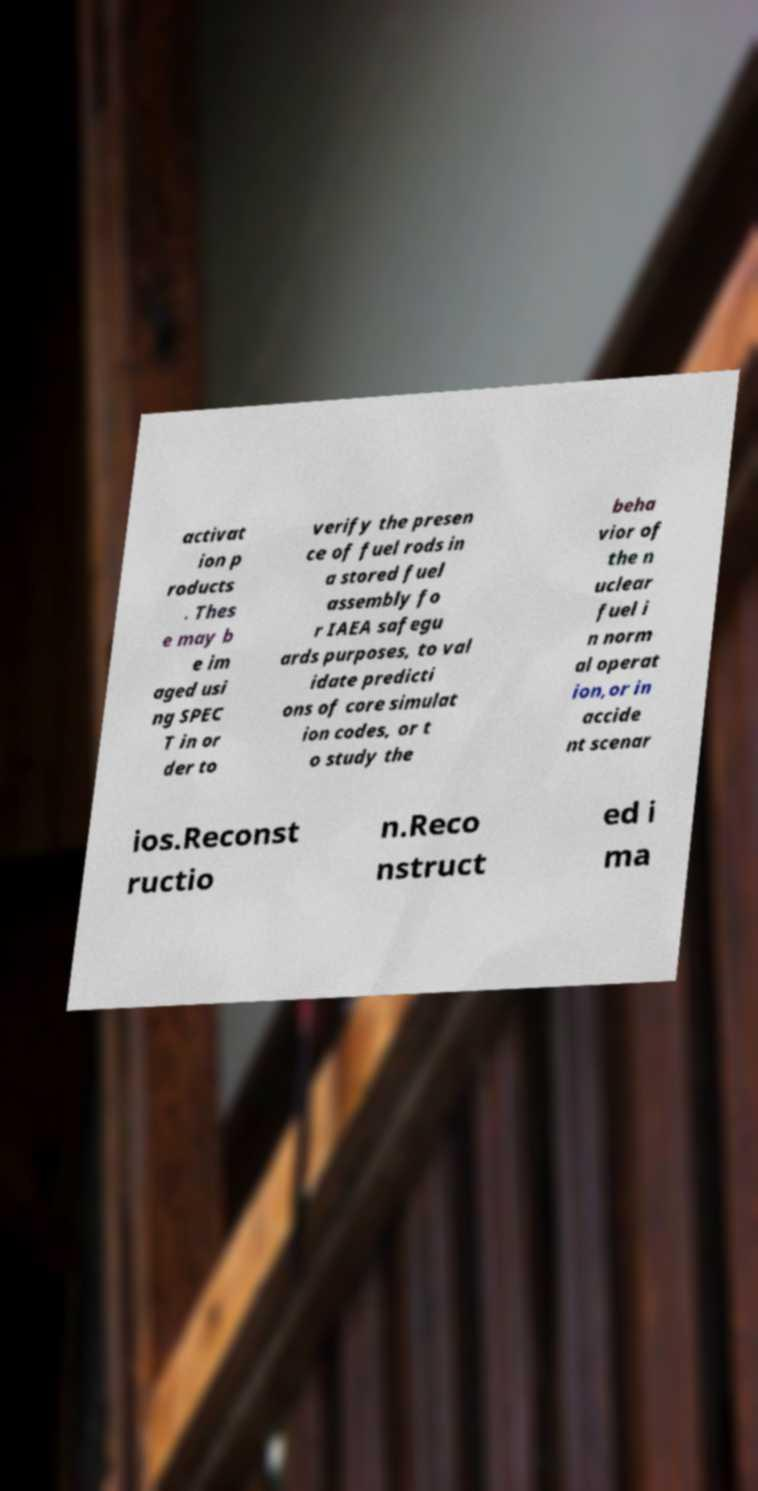Could you extract and type out the text from this image? activat ion p roducts . Thes e may b e im aged usi ng SPEC T in or der to verify the presen ce of fuel rods in a stored fuel assembly fo r IAEA safegu ards purposes, to val idate predicti ons of core simulat ion codes, or t o study the beha vior of the n uclear fuel i n norm al operat ion,or in accide nt scenar ios.Reconst ructio n.Reco nstruct ed i ma 